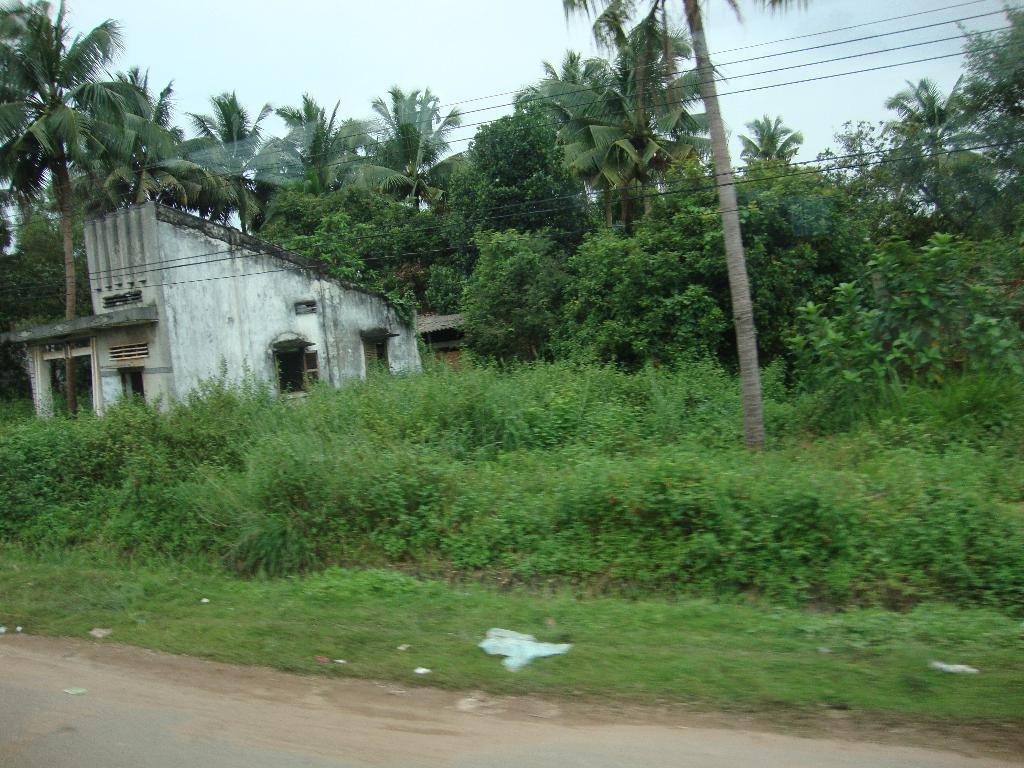What type of vegetation can be seen in the image? There is grass, plants, and trees in the image. What else is present in the image besides vegetation? Cables and houses are visible in the image. Can you describe the type of cables in the image? The cables are visible in the image, but their specific type is not mentioned. How many houses can be seen in the image? There are houses in the image, but the exact number is not specified. What type of collar can be seen on the actor in the image? There is no actor or collar present in the image. What type of net is being used to catch the birds in the image? There are no birds or nets present in the image. 